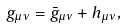<formula> <loc_0><loc_0><loc_500><loc_500>g _ { \mu \nu } = \bar { g } _ { \mu \nu } + h _ { \mu \nu } ,</formula> 